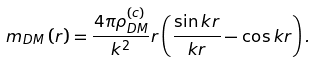Convert formula to latex. <formula><loc_0><loc_0><loc_500><loc_500>m _ { D M } \left ( r \right ) = \frac { 4 \pi \rho _ { D M } ^ { ( c ) } } { k ^ { 2 } } r \left ( \frac { \sin k r } { k r } - \cos k r \right ) .</formula> 